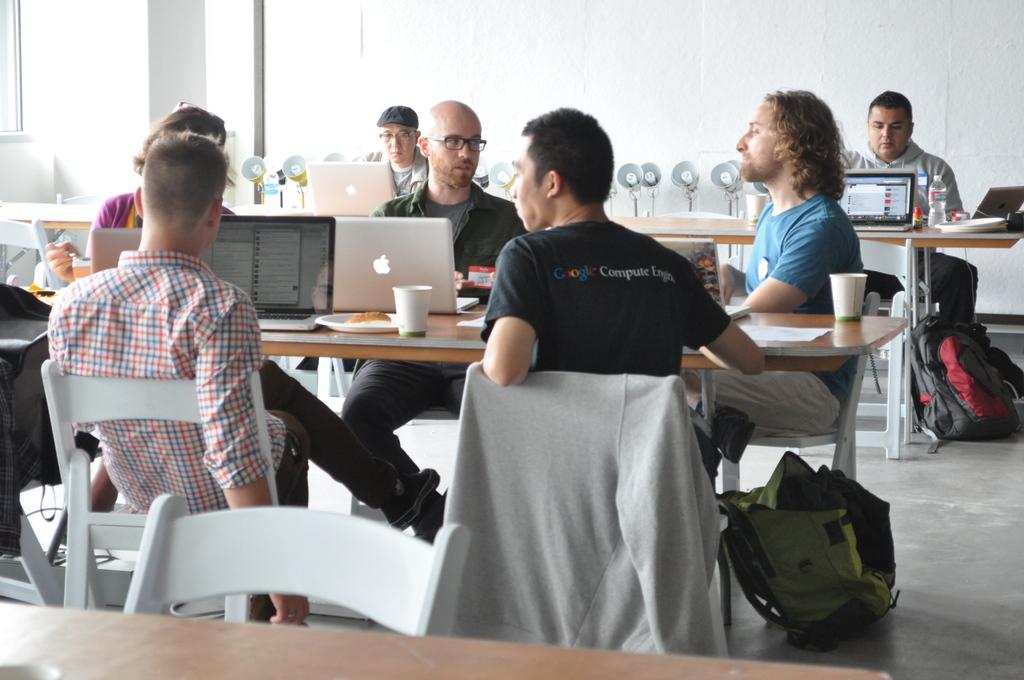What does his shirt say on the back?
Provide a short and direct response. Google compute engine. 